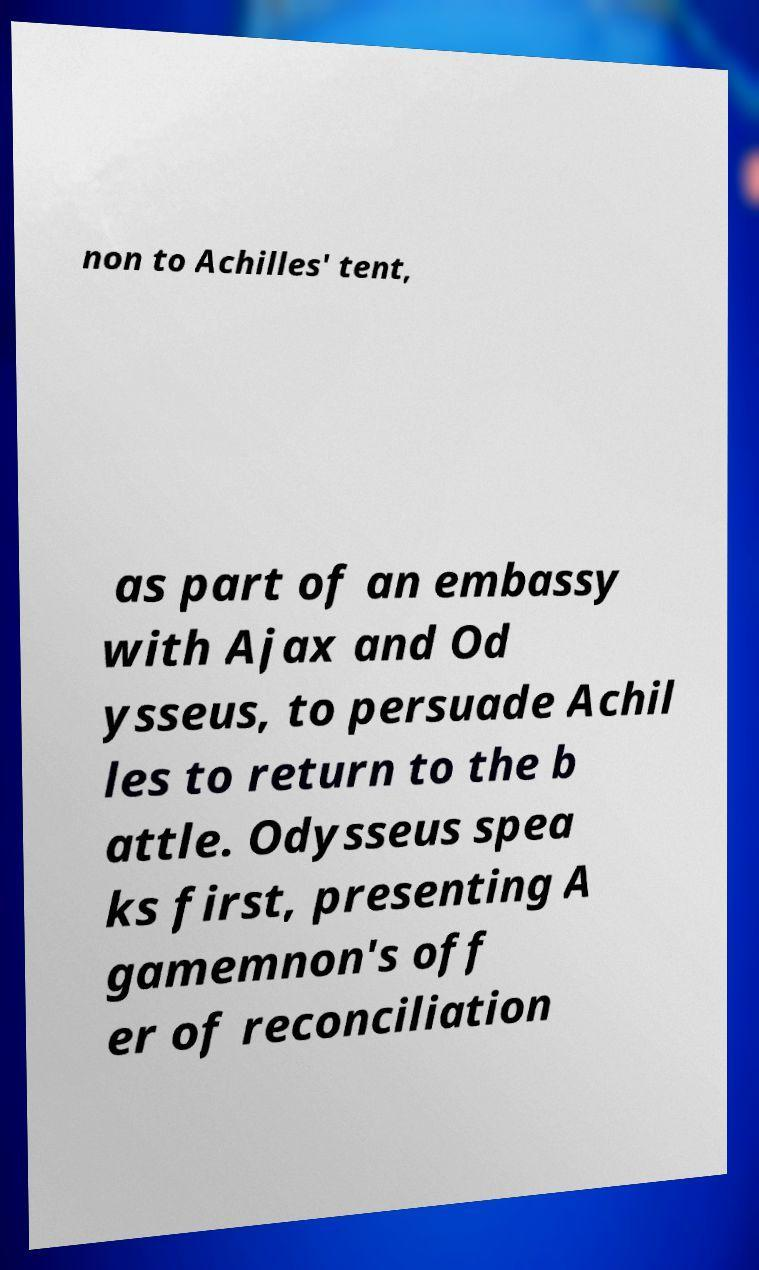Please identify and transcribe the text found in this image. non to Achilles' tent, as part of an embassy with Ajax and Od ysseus, to persuade Achil les to return to the b attle. Odysseus spea ks first, presenting A gamemnon's off er of reconciliation 